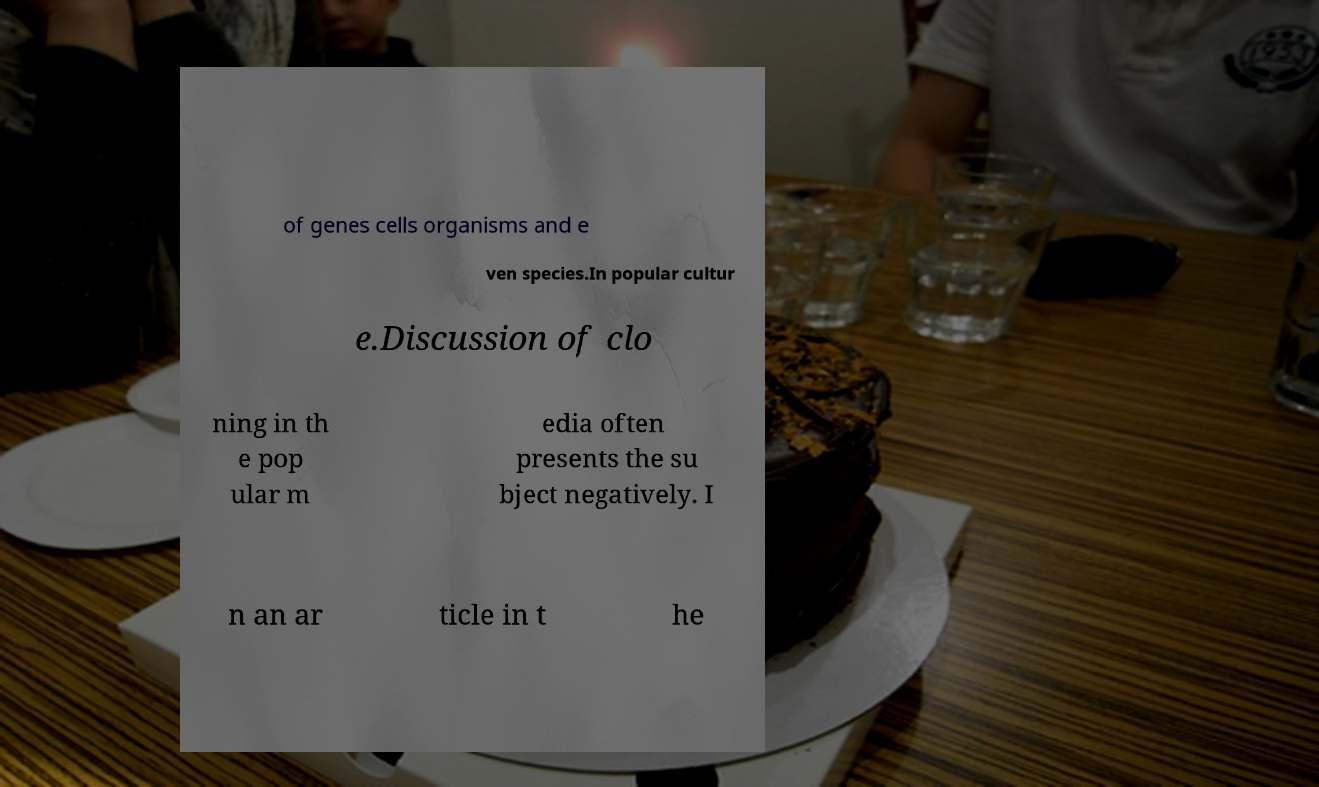Could you extract and type out the text from this image? of genes cells organisms and e ven species.In popular cultur e.Discussion of clo ning in th e pop ular m edia often presents the su bject negatively. I n an ar ticle in t he 